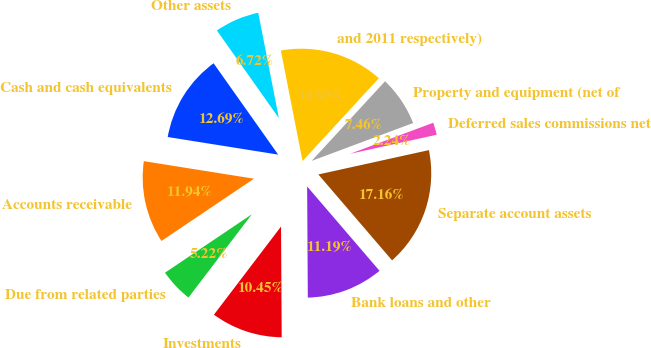<chart> <loc_0><loc_0><loc_500><loc_500><pie_chart><fcel>Cash and cash equivalents<fcel>Accounts receivable<fcel>Due from related parties<fcel>Investments<fcel>Bank loans and other<fcel>Separate account assets<fcel>Deferred sales commissions net<fcel>Property and equipment (net of<fcel>and 2011 respectively)<fcel>Other assets<nl><fcel>12.69%<fcel>11.94%<fcel>5.22%<fcel>10.45%<fcel>11.19%<fcel>17.16%<fcel>2.24%<fcel>7.46%<fcel>14.93%<fcel>6.72%<nl></chart> 